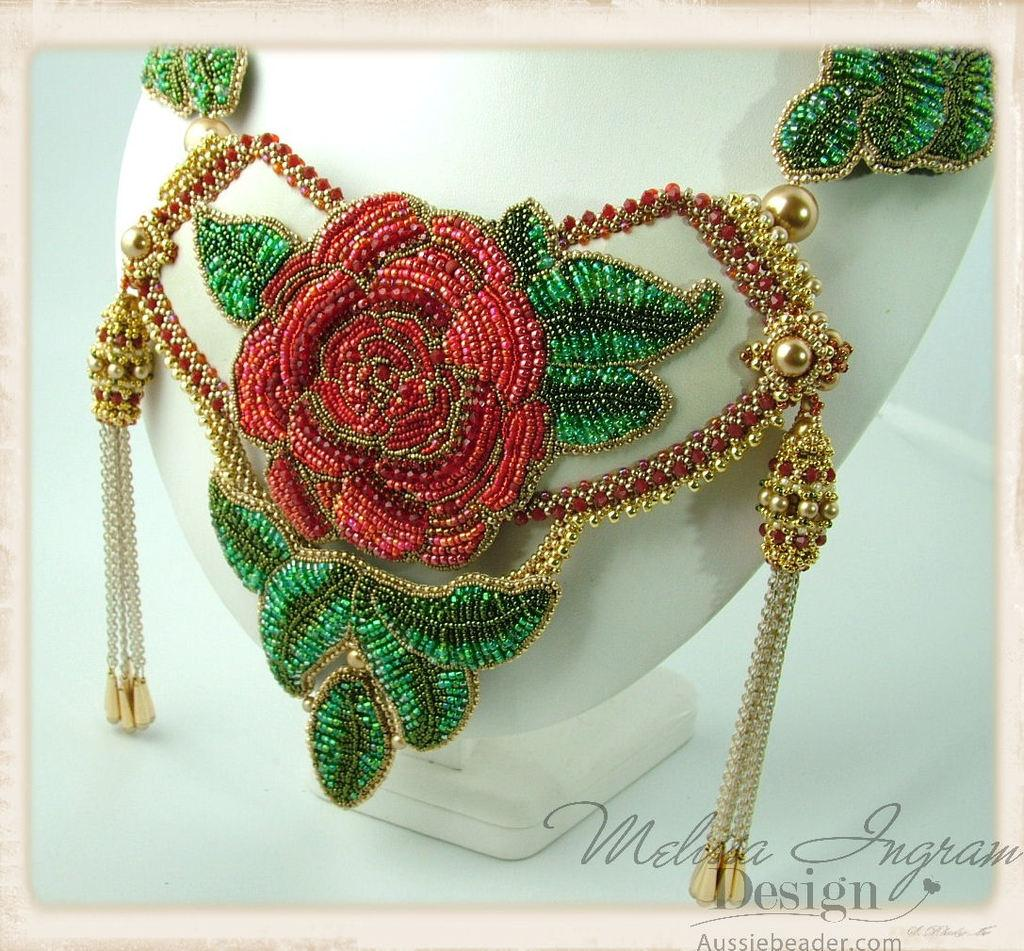What type of object is featured in the image? There is a jewelry item in the image. What is the jewelry item placed on? The jewelry item is on a white-colored object. What type of school is depicted in the image? There is no school depicted in the image; it features a jewelry item on a white-colored object. 